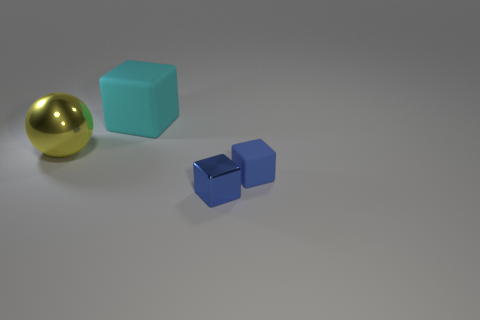How many small things are either yellow things or blue balls?
Make the answer very short. 0. What size is the block behind the blue matte cube?
Provide a succinct answer. Large. Is there a large metal cylinder that has the same color as the tiny metallic object?
Keep it short and to the point. No. Does the shiny cube have the same color as the large block?
Provide a succinct answer. No. There is a tiny shiny thing that is the same color as the small matte object; what shape is it?
Your answer should be compact. Cube. There is a matte thing that is behind the sphere; what number of big rubber blocks are left of it?
Make the answer very short. 0. How many large balls are the same material as the large cyan thing?
Keep it short and to the point. 0. There is a big cyan block; are there any metallic blocks to the left of it?
Provide a short and direct response. No. What is the color of the object that is the same size as the yellow metal ball?
Make the answer very short. Cyan. How many objects are either large things that are in front of the cyan rubber block or large balls?
Give a very brief answer. 1. 